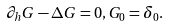<formula> <loc_0><loc_0><loc_500><loc_500>\partial _ { h } G - \Delta G = 0 , G _ { 0 } = \delta _ { 0 } .</formula> 